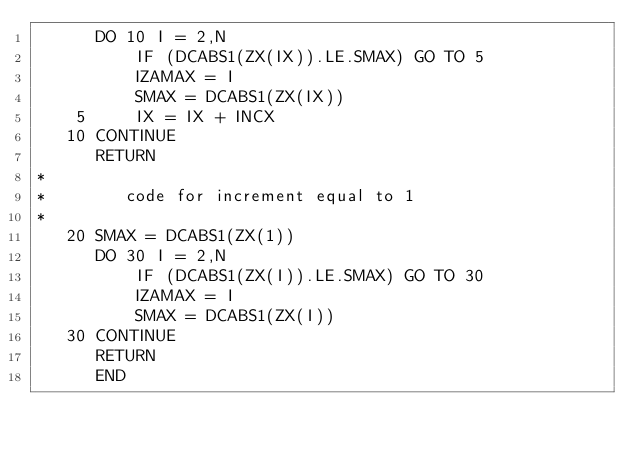Convert code to text. <code><loc_0><loc_0><loc_500><loc_500><_FORTRAN_>      DO 10 I = 2,N
          IF (DCABS1(ZX(IX)).LE.SMAX) GO TO 5
          IZAMAX = I
          SMAX = DCABS1(ZX(IX))
    5     IX = IX + INCX
   10 CONTINUE
      RETURN
*
*        code for increment equal to 1
*
   20 SMAX = DCABS1(ZX(1))
      DO 30 I = 2,N
          IF (DCABS1(ZX(I)).LE.SMAX) GO TO 30
          IZAMAX = I
          SMAX = DCABS1(ZX(I))
   30 CONTINUE
      RETURN
      END
</code> 